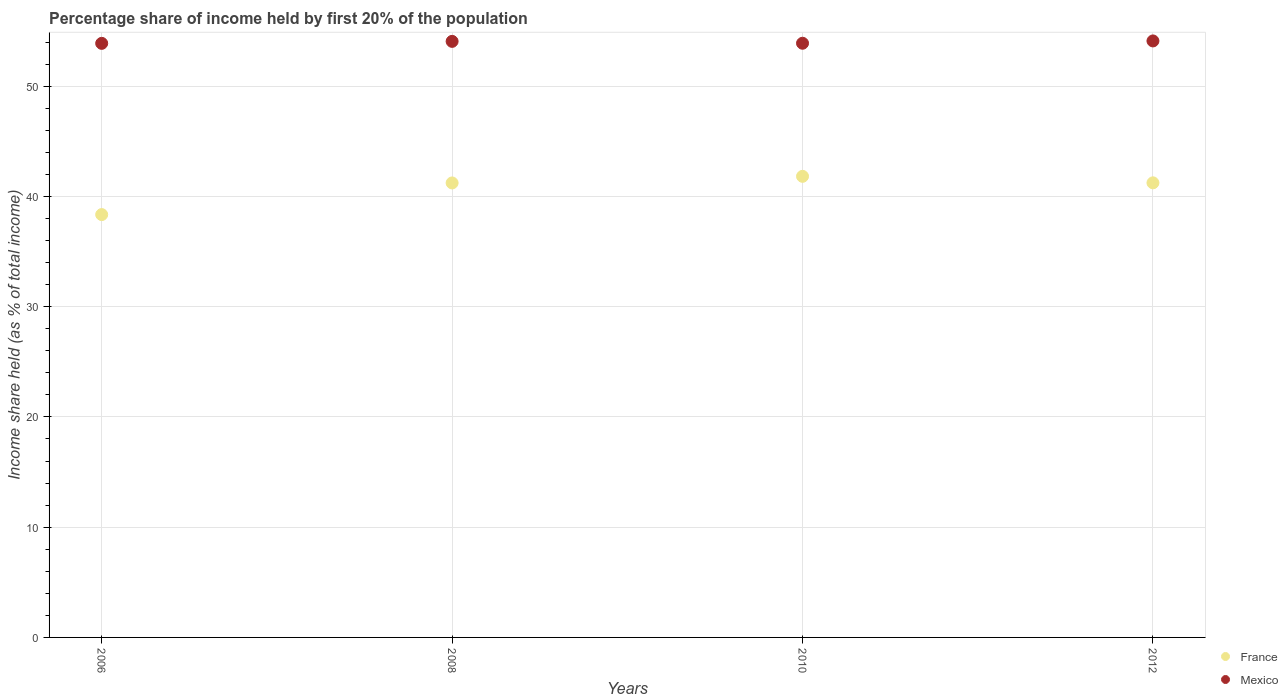How many different coloured dotlines are there?
Your answer should be compact. 2. Is the number of dotlines equal to the number of legend labels?
Keep it short and to the point. Yes. What is the share of income held by first 20% of the population in France in 2008?
Provide a short and direct response. 41.22. Across all years, what is the maximum share of income held by first 20% of the population in Mexico?
Keep it short and to the point. 54.1. Across all years, what is the minimum share of income held by first 20% of the population in Mexico?
Your answer should be compact. 53.88. What is the total share of income held by first 20% of the population in Mexico in the graph?
Your answer should be compact. 215.93. What is the difference between the share of income held by first 20% of the population in France in 2008 and that in 2012?
Offer a very short reply. -0.01. What is the difference between the share of income held by first 20% of the population in France in 2012 and the share of income held by first 20% of the population in Mexico in 2008?
Ensure brevity in your answer.  -12.83. What is the average share of income held by first 20% of the population in France per year?
Offer a very short reply. 40.65. In the year 2010, what is the difference between the share of income held by first 20% of the population in Mexico and share of income held by first 20% of the population in France?
Your response must be concise. 12.07. In how many years, is the share of income held by first 20% of the population in Mexico greater than 50 %?
Offer a terse response. 4. What is the ratio of the share of income held by first 20% of the population in Mexico in 2008 to that in 2010?
Offer a very short reply. 1. Is the share of income held by first 20% of the population in Mexico in 2008 less than that in 2010?
Give a very brief answer. No. What is the difference between the highest and the second highest share of income held by first 20% of the population in France?
Your response must be concise. 0.59. What is the difference between the highest and the lowest share of income held by first 20% of the population in Mexico?
Offer a very short reply. 0.22. In how many years, is the share of income held by first 20% of the population in France greater than the average share of income held by first 20% of the population in France taken over all years?
Your answer should be very brief. 3. Is the sum of the share of income held by first 20% of the population in Mexico in 2010 and 2012 greater than the maximum share of income held by first 20% of the population in France across all years?
Your response must be concise. Yes. Does the share of income held by first 20% of the population in France monotonically increase over the years?
Your answer should be very brief. No. Is the share of income held by first 20% of the population in Mexico strictly greater than the share of income held by first 20% of the population in France over the years?
Your answer should be very brief. Yes. Is the share of income held by first 20% of the population in France strictly less than the share of income held by first 20% of the population in Mexico over the years?
Your answer should be compact. Yes. How many dotlines are there?
Provide a short and direct response. 2. How many years are there in the graph?
Make the answer very short. 4. Are the values on the major ticks of Y-axis written in scientific E-notation?
Your answer should be very brief. No. Where does the legend appear in the graph?
Give a very brief answer. Bottom right. How are the legend labels stacked?
Offer a terse response. Vertical. What is the title of the graph?
Your answer should be very brief. Percentage share of income held by first 20% of the population. What is the label or title of the Y-axis?
Provide a short and direct response. Income share held (as % of total income). What is the Income share held (as % of total income) in France in 2006?
Your answer should be very brief. 38.35. What is the Income share held (as % of total income) of Mexico in 2006?
Keep it short and to the point. 53.88. What is the Income share held (as % of total income) of France in 2008?
Your response must be concise. 41.22. What is the Income share held (as % of total income) in Mexico in 2008?
Provide a short and direct response. 54.06. What is the Income share held (as % of total income) in France in 2010?
Your answer should be very brief. 41.82. What is the Income share held (as % of total income) of Mexico in 2010?
Your answer should be very brief. 53.89. What is the Income share held (as % of total income) of France in 2012?
Offer a terse response. 41.23. What is the Income share held (as % of total income) of Mexico in 2012?
Your answer should be very brief. 54.1. Across all years, what is the maximum Income share held (as % of total income) in France?
Offer a very short reply. 41.82. Across all years, what is the maximum Income share held (as % of total income) of Mexico?
Your response must be concise. 54.1. Across all years, what is the minimum Income share held (as % of total income) of France?
Make the answer very short. 38.35. Across all years, what is the minimum Income share held (as % of total income) of Mexico?
Your answer should be very brief. 53.88. What is the total Income share held (as % of total income) in France in the graph?
Ensure brevity in your answer.  162.62. What is the total Income share held (as % of total income) of Mexico in the graph?
Offer a very short reply. 215.93. What is the difference between the Income share held (as % of total income) in France in 2006 and that in 2008?
Provide a succinct answer. -2.87. What is the difference between the Income share held (as % of total income) in Mexico in 2006 and that in 2008?
Make the answer very short. -0.18. What is the difference between the Income share held (as % of total income) of France in 2006 and that in 2010?
Your answer should be compact. -3.47. What is the difference between the Income share held (as % of total income) in Mexico in 2006 and that in 2010?
Offer a very short reply. -0.01. What is the difference between the Income share held (as % of total income) in France in 2006 and that in 2012?
Offer a terse response. -2.88. What is the difference between the Income share held (as % of total income) of Mexico in 2006 and that in 2012?
Provide a short and direct response. -0.22. What is the difference between the Income share held (as % of total income) in Mexico in 2008 and that in 2010?
Offer a terse response. 0.17. What is the difference between the Income share held (as % of total income) in France in 2008 and that in 2012?
Provide a short and direct response. -0.01. What is the difference between the Income share held (as % of total income) of Mexico in 2008 and that in 2012?
Provide a succinct answer. -0.04. What is the difference between the Income share held (as % of total income) in France in 2010 and that in 2012?
Provide a succinct answer. 0.59. What is the difference between the Income share held (as % of total income) in Mexico in 2010 and that in 2012?
Keep it short and to the point. -0.21. What is the difference between the Income share held (as % of total income) of France in 2006 and the Income share held (as % of total income) of Mexico in 2008?
Keep it short and to the point. -15.71. What is the difference between the Income share held (as % of total income) of France in 2006 and the Income share held (as % of total income) of Mexico in 2010?
Keep it short and to the point. -15.54. What is the difference between the Income share held (as % of total income) in France in 2006 and the Income share held (as % of total income) in Mexico in 2012?
Keep it short and to the point. -15.75. What is the difference between the Income share held (as % of total income) in France in 2008 and the Income share held (as % of total income) in Mexico in 2010?
Your answer should be compact. -12.67. What is the difference between the Income share held (as % of total income) in France in 2008 and the Income share held (as % of total income) in Mexico in 2012?
Keep it short and to the point. -12.88. What is the difference between the Income share held (as % of total income) in France in 2010 and the Income share held (as % of total income) in Mexico in 2012?
Your answer should be compact. -12.28. What is the average Income share held (as % of total income) of France per year?
Offer a terse response. 40.66. What is the average Income share held (as % of total income) in Mexico per year?
Provide a short and direct response. 53.98. In the year 2006, what is the difference between the Income share held (as % of total income) of France and Income share held (as % of total income) of Mexico?
Provide a short and direct response. -15.53. In the year 2008, what is the difference between the Income share held (as % of total income) of France and Income share held (as % of total income) of Mexico?
Your response must be concise. -12.84. In the year 2010, what is the difference between the Income share held (as % of total income) of France and Income share held (as % of total income) of Mexico?
Your response must be concise. -12.07. In the year 2012, what is the difference between the Income share held (as % of total income) in France and Income share held (as % of total income) in Mexico?
Offer a terse response. -12.87. What is the ratio of the Income share held (as % of total income) of France in 2006 to that in 2008?
Keep it short and to the point. 0.93. What is the ratio of the Income share held (as % of total income) in France in 2006 to that in 2010?
Provide a short and direct response. 0.92. What is the ratio of the Income share held (as % of total income) in Mexico in 2006 to that in 2010?
Ensure brevity in your answer.  1. What is the ratio of the Income share held (as % of total income) in France in 2006 to that in 2012?
Keep it short and to the point. 0.93. What is the ratio of the Income share held (as % of total income) in Mexico in 2006 to that in 2012?
Provide a succinct answer. 1. What is the ratio of the Income share held (as % of total income) in France in 2008 to that in 2010?
Make the answer very short. 0.99. What is the ratio of the Income share held (as % of total income) of Mexico in 2008 to that in 2012?
Make the answer very short. 1. What is the ratio of the Income share held (as % of total income) in France in 2010 to that in 2012?
Provide a short and direct response. 1.01. What is the difference between the highest and the second highest Income share held (as % of total income) in France?
Keep it short and to the point. 0.59. What is the difference between the highest and the lowest Income share held (as % of total income) in France?
Your answer should be compact. 3.47. What is the difference between the highest and the lowest Income share held (as % of total income) of Mexico?
Offer a very short reply. 0.22. 